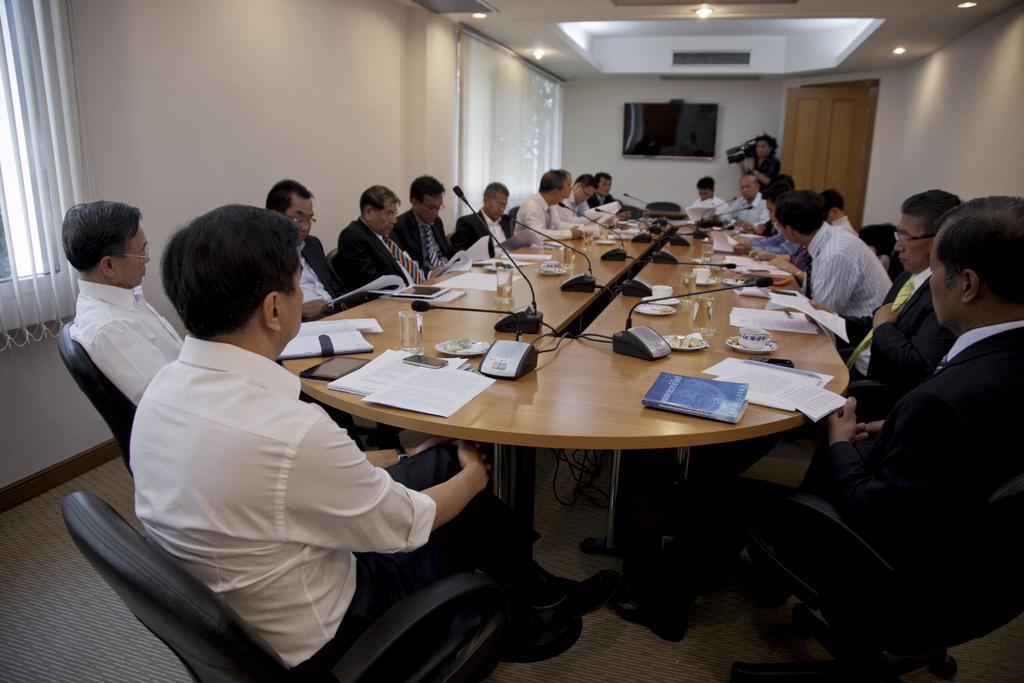Could you give a brief overview of what you see in this image? This picture is of inside the conference room and there are group of persons sitting on the chairs around the table. In the center there is a table on the top of which microphones, glasses and some papers are placed. In the background we can see a door, a wall mounted television and a person holding a camera and standing. 